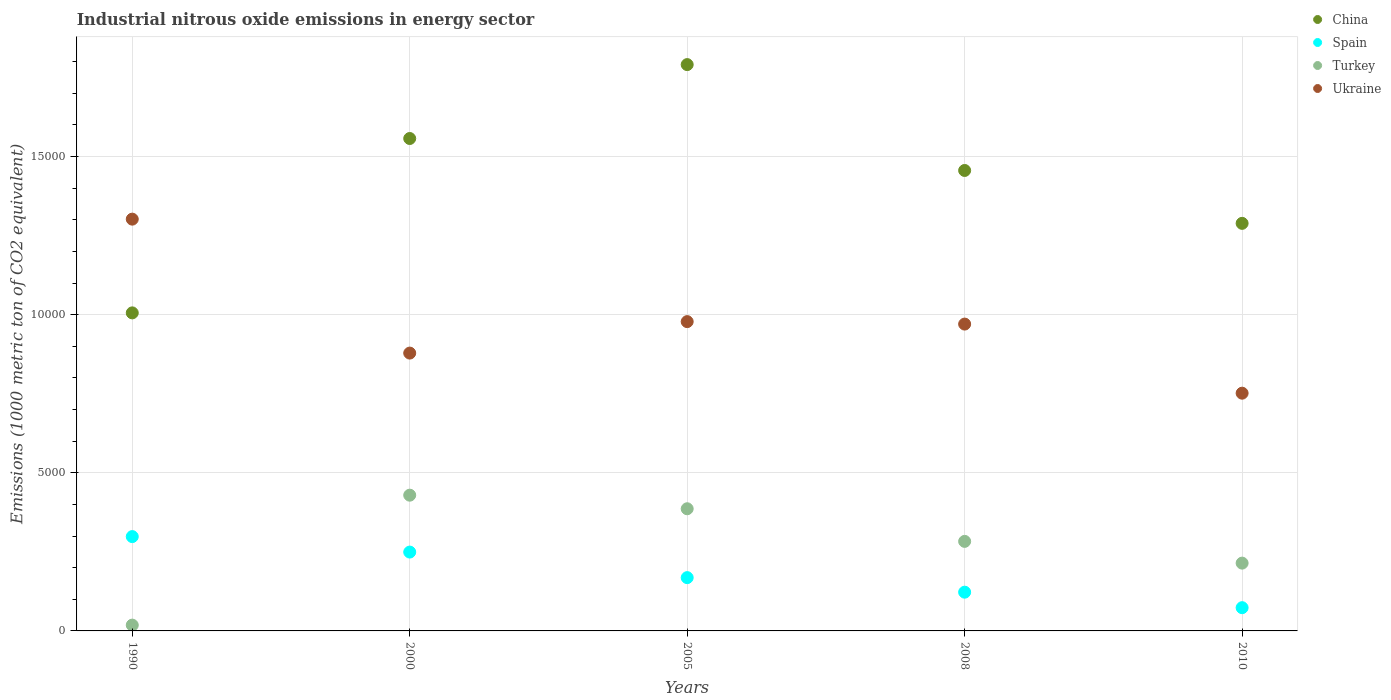How many different coloured dotlines are there?
Your response must be concise. 4. Is the number of dotlines equal to the number of legend labels?
Your answer should be compact. Yes. What is the amount of industrial nitrous oxide emitted in Spain in 1990?
Make the answer very short. 2982.4. Across all years, what is the maximum amount of industrial nitrous oxide emitted in Turkey?
Offer a very short reply. 4292. Across all years, what is the minimum amount of industrial nitrous oxide emitted in Ukraine?
Offer a terse response. 7516.9. In which year was the amount of industrial nitrous oxide emitted in Ukraine maximum?
Offer a terse response. 1990. What is the total amount of industrial nitrous oxide emitted in Spain in the graph?
Make the answer very short. 9120.2. What is the difference between the amount of industrial nitrous oxide emitted in China in 2005 and that in 2010?
Your answer should be very brief. 5019.4. What is the difference between the amount of industrial nitrous oxide emitted in Turkey in 2000 and the amount of industrial nitrous oxide emitted in China in 1990?
Your answer should be very brief. -5764.1. What is the average amount of industrial nitrous oxide emitted in Turkey per year?
Make the answer very short. 2662.68. In the year 2005, what is the difference between the amount of industrial nitrous oxide emitted in China and amount of industrial nitrous oxide emitted in Ukraine?
Keep it short and to the point. 8126.5. What is the ratio of the amount of industrial nitrous oxide emitted in China in 1990 to that in 2010?
Provide a succinct answer. 0.78. Is the amount of industrial nitrous oxide emitted in China in 2008 less than that in 2010?
Keep it short and to the point. No. Is the difference between the amount of industrial nitrous oxide emitted in China in 1990 and 2010 greater than the difference between the amount of industrial nitrous oxide emitted in Ukraine in 1990 and 2010?
Provide a succinct answer. No. What is the difference between the highest and the second highest amount of industrial nitrous oxide emitted in Turkey?
Provide a short and direct response. 429.3. What is the difference between the highest and the lowest amount of industrial nitrous oxide emitted in Turkey?
Keep it short and to the point. 4108.4. In how many years, is the amount of industrial nitrous oxide emitted in Ukraine greater than the average amount of industrial nitrous oxide emitted in Ukraine taken over all years?
Ensure brevity in your answer.  2. Is the sum of the amount of industrial nitrous oxide emitted in Turkey in 2000 and 2010 greater than the maximum amount of industrial nitrous oxide emitted in Spain across all years?
Your answer should be compact. Yes. Is it the case that in every year, the sum of the amount of industrial nitrous oxide emitted in China and amount of industrial nitrous oxide emitted in Turkey  is greater than the sum of amount of industrial nitrous oxide emitted in Spain and amount of industrial nitrous oxide emitted in Ukraine?
Make the answer very short. No. Does the amount of industrial nitrous oxide emitted in China monotonically increase over the years?
Provide a succinct answer. No. Is the amount of industrial nitrous oxide emitted in Turkey strictly greater than the amount of industrial nitrous oxide emitted in Spain over the years?
Offer a terse response. No. How many years are there in the graph?
Give a very brief answer. 5. Where does the legend appear in the graph?
Your answer should be very brief. Top right. What is the title of the graph?
Your answer should be compact. Industrial nitrous oxide emissions in energy sector. Does "Mauritius" appear as one of the legend labels in the graph?
Give a very brief answer. No. What is the label or title of the X-axis?
Your answer should be very brief. Years. What is the label or title of the Y-axis?
Keep it short and to the point. Emissions (1000 metric ton of CO2 equivalent). What is the Emissions (1000 metric ton of CO2 equivalent) in China in 1990?
Your response must be concise. 1.01e+04. What is the Emissions (1000 metric ton of CO2 equivalent) of Spain in 1990?
Your answer should be compact. 2982.4. What is the Emissions (1000 metric ton of CO2 equivalent) of Turkey in 1990?
Your answer should be very brief. 183.6. What is the Emissions (1000 metric ton of CO2 equivalent) in Ukraine in 1990?
Make the answer very short. 1.30e+04. What is the Emissions (1000 metric ton of CO2 equivalent) in China in 2000?
Offer a terse response. 1.56e+04. What is the Emissions (1000 metric ton of CO2 equivalent) in Spain in 2000?
Ensure brevity in your answer.  2493. What is the Emissions (1000 metric ton of CO2 equivalent) in Turkey in 2000?
Your answer should be very brief. 4292. What is the Emissions (1000 metric ton of CO2 equivalent) of Ukraine in 2000?
Offer a terse response. 8784.8. What is the Emissions (1000 metric ton of CO2 equivalent) in China in 2005?
Offer a terse response. 1.79e+04. What is the Emissions (1000 metric ton of CO2 equivalent) in Spain in 2005?
Your answer should be very brief. 1685.1. What is the Emissions (1000 metric ton of CO2 equivalent) of Turkey in 2005?
Offer a very short reply. 3862.7. What is the Emissions (1000 metric ton of CO2 equivalent) of Ukraine in 2005?
Your answer should be very brief. 9779.9. What is the Emissions (1000 metric ton of CO2 equivalent) of China in 2008?
Offer a very short reply. 1.46e+04. What is the Emissions (1000 metric ton of CO2 equivalent) in Spain in 2008?
Offer a terse response. 1224.9. What is the Emissions (1000 metric ton of CO2 equivalent) in Turkey in 2008?
Make the answer very short. 2831.3. What is the Emissions (1000 metric ton of CO2 equivalent) in Ukraine in 2008?
Give a very brief answer. 9701.8. What is the Emissions (1000 metric ton of CO2 equivalent) in China in 2010?
Offer a terse response. 1.29e+04. What is the Emissions (1000 metric ton of CO2 equivalent) of Spain in 2010?
Provide a short and direct response. 734.8. What is the Emissions (1000 metric ton of CO2 equivalent) in Turkey in 2010?
Offer a very short reply. 2143.8. What is the Emissions (1000 metric ton of CO2 equivalent) of Ukraine in 2010?
Provide a succinct answer. 7516.9. Across all years, what is the maximum Emissions (1000 metric ton of CO2 equivalent) of China?
Provide a succinct answer. 1.79e+04. Across all years, what is the maximum Emissions (1000 metric ton of CO2 equivalent) in Spain?
Give a very brief answer. 2982.4. Across all years, what is the maximum Emissions (1000 metric ton of CO2 equivalent) in Turkey?
Offer a very short reply. 4292. Across all years, what is the maximum Emissions (1000 metric ton of CO2 equivalent) in Ukraine?
Ensure brevity in your answer.  1.30e+04. Across all years, what is the minimum Emissions (1000 metric ton of CO2 equivalent) in China?
Provide a short and direct response. 1.01e+04. Across all years, what is the minimum Emissions (1000 metric ton of CO2 equivalent) of Spain?
Your answer should be compact. 734.8. Across all years, what is the minimum Emissions (1000 metric ton of CO2 equivalent) of Turkey?
Provide a succinct answer. 183.6. Across all years, what is the minimum Emissions (1000 metric ton of CO2 equivalent) of Ukraine?
Provide a short and direct response. 7516.9. What is the total Emissions (1000 metric ton of CO2 equivalent) of China in the graph?
Keep it short and to the point. 7.10e+04. What is the total Emissions (1000 metric ton of CO2 equivalent) of Spain in the graph?
Keep it short and to the point. 9120.2. What is the total Emissions (1000 metric ton of CO2 equivalent) of Turkey in the graph?
Give a very brief answer. 1.33e+04. What is the total Emissions (1000 metric ton of CO2 equivalent) in Ukraine in the graph?
Your answer should be very brief. 4.88e+04. What is the difference between the Emissions (1000 metric ton of CO2 equivalent) in China in 1990 and that in 2000?
Provide a succinct answer. -5513.6. What is the difference between the Emissions (1000 metric ton of CO2 equivalent) of Spain in 1990 and that in 2000?
Your answer should be compact. 489.4. What is the difference between the Emissions (1000 metric ton of CO2 equivalent) of Turkey in 1990 and that in 2000?
Your answer should be very brief. -4108.4. What is the difference between the Emissions (1000 metric ton of CO2 equivalent) of Ukraine in 1990 and that in 2000?
Offer a very short reply. 4235.2. What is the difference between the Emissions (1000 metric ton of CO2 equivalent) of China in 1990 and that in 2005?
Your answer should be very brief. -7850.3. What is the difference between the Emissions (1000 metric ton of CO2 equivalent) in Spain in 1990 and that in 2005?
Your answer should be very brief. 1297.3. What is the difference between the Emissions (1000 metric ton of CO2 equivalent) of Turkey in 1990 and that in 2005?
Ensure brevity in your answer.  -3679.1. What is the difference between the Emissions (1000 metric ton of CO2 equivalent) of Ukraine in 1990 and that in 2005?
Keep it short and to the point. 3240.1. What is the difference between the Emissions (1000 metric ton of CO2 equivalent) in China in 1990 and that in 2008?
Keep it short and to the point. -4502.8. What is the difference between the Emissions (1000 metric ton of CO2 equivalent) in Spain in 1990 and that in 2008?
Provide a succinct answer. 1757.5. What is the difference between the Emissions (1000 metric ton of CO2 equivalent) of Turkey in 1990 and that in 2008?
Provide a succinct answer. -2647.7. What is the difference between the Emissions (1000 metric ton of CO2 equivalent) of Ukraine in 1990 and that in 2008?
Make the answer very short. 3318.2. What is the difference between the Emissions (1000 metric ton of CO2 equivalent) in China in 1990 and that in 2010?
Give a very brief answer. -2830.9. What is the difference between the Emissions (1000 metric ton of CO2 equivalent) in Spain in 1990 and that in 2010?
Your answer should be very brief. 2247.6. What is the difference between the Emissions (1000 metric ton of CO2 equivalent) in Turkey in 1990 and that in 2010?
Give a very brief answer. -1960.2. What is the difference between the Emissions (1000 metric ton of CO2 equivalent) of Ukraine in 1990 and that in 2010?
Provide a short and direct response. 5503.1. What is the difference between the Emissions (1000 metric ton of CO2 equivalent) in China in 2000 and that in 2005?
Offer a very short reply. -2336.7. What is the difference between the Emissions (1000 metric ton of CO2 equivalent) in Spain in 2000 and that in 2005?
Ensure brevity in your answer.  807.9. What is the difference between the Emissions (1000 metric ton of CO2 equivalent) of Turkey in 2000 and that in 2005?
Offer a very short reply. 429.3. What is the difference between the Emissions (1000 metric ton of CO2 equivalent) in Ukraine in 2000 and that in 2005?
Make the answer very short. -995.1. What is the difference between the Emissions (1000 metric ton of CO2 equivalent) in China in 2000 and that in 2008?
Make the answer very short. 1010.8. What is the difference between the Emissions (1000 metric ton of CO2 equivalent) in Spain in 2000 and that in 2008?
Your response must be concise. 1268.1. What is the difference between the Emissions (1000 metric ton of CO2 equivalent) in Turkey in 2000 and that in 2008?
Your answer should be very brief. 1460.7. What is the difference between the Emissions (1000 metric ton of CO2 equivalent) in Ukraine in 2000 and that in 2008?
Your response must be concise. -917. What is the difference between the Emissions (1000 metric ton of CO2 equivalent) in China in 2000 and that in 2010?
Ensure brevity in your answer.  2682.7. What is the difference between the Emissions (1000 metric ton of CO2 equivalent) in Spain in 2000 and that in 2010?
Your response must be concise. 1758.2. What is the difference between the Emissions (1000 metric ton of CO2 equivalent) of Turkey in 2000 and that in 2010?
Ensure brevity in your answer.  2148.2. What is the difference between the Emissions (1000 metric ton of CO2 equivalent) in Ukraine in 2000 and that in 2010?
Give a very brief answer. 1267.9. What is the difference between the Emissions (1000 metric ton of CO2 equivalent) of China in 2005 and that in 2008?
Your answer should be compact. 3347.5. What is the difference between the Emissions (1000 metric ton of CO2 equivalent) in Spain in 2005 and that in 2008?
Provide a succinct answer. 460.2. What is the difference between the Emissions (1000 metric ton of CO2 equivalent) of Turkey in 2005 and that in 2008?
Give a very brief answer. 1031.4. What is the difference between the Emissions (1000 metric ton of CO2 equivalent) in Ukraine in 2005 and that in 2008?
Make the answer very short. 78.1. What is the difference between the Emissions (1000 metric ton of CO2 equivalent) in China in 2005 and that in 2010?
Make the answer very short. 5019.4. What is the difference between the Emissions (1000 metric ton of CO2 equivalent) in Spain in 2005 and that in 2010?
Provide a succinct answer. 950.3. What is the difference between the Emissions (1000 metric ton of CO2 equivalent) of Turkey in 2005 and that in 2010?
Give a very brief answer. 1718.9. What is the difference between the Emissions (1000 metric ton of CO2 equivalent) in Ukraine in 2005 and that in 2010?
Provide a succinct answer. 2263. What is the difference between the Emissions (1000 metric ton of CO2 equivalent) in China in 2008 and that in 2010?
Make the answer very short. 1671.9. What is the difference between the Emissions (1000 metric ton of CO2 equivalent) in Spain in 2008 and that in 2010?
Provide a short and direct response. 490.1. What is the difference between the Emissions (1000 metric ton of CO2 equivalent) in Turkey in 2008 and that in 2010?
Your response must be concise. 687.5. What is the difference between the Emissions (1000 metric ton of CO2 equivalent) in Ukraine in 2008 and that in 2010?
Your response must be concise. 2184.9. What is the difference between the Emissions (1000 metric ton of CO2 equivalent) of China in 1990 and the Emissions (1000 metric ton of CO2 equivalent) of Spain in 2000?
Offer a very short reply. 7563.1. What is the difference between the Emissions (1000 metric ton of CO2 equivalent) of China in 1990 and the Emissions (1000 metric ton of CO2 equivalent) of Turkey in 2000?
Your answer should be very brief. 5764.1. What is the difference between the Emissions (1000 metric ton of CO2 equivalent) of China in 1990 and the Emissions (1000 metric ton of CO2 equivalent) of Ukraine in 2000?
Offer a very short reply. 1271.3. What is the difference between the Emissions (1000 metric ton of CO2 equivalent) of Spain in 1990 and the Emissions (1000 metric ton of CO2 equivalent) of Turkey in 2000?
Give a very brief answer. -1309.6. What is the difference between the Emissions (1000 metric ton of CO2 equivalent) of Spain in 1990 and the Emissions (1000 metric ton of CO2 equivalent) of Ukraine in 2000?
Provide a short and direct response. -5802.4. What is the difference between the Emissions (1000 metric ton of CO2 equivalent) of Turkey in 1990 and the Emissions (1000 metric ton of CO2 equivalent) of Ukraine in 2000?
Offer a terse response. -8601.2. What is the difference between the Emissions (1000 metric ton of CO2 equivalent) in China in 1990 and the Emissions (1000 metric ton of CO2 equivalent) in Spain in 2005?
Your answer should be very brief. 8371. What is the difference between the Emissions (1000 metric ton of CO2 equivalent) of China in 1990 and the Emissions (1000 metric ton of CO2 equivalent) of Turkey in 2005?
Give a very brief answer. 6193.4. What is the difference between the Emissions (1000 metric ton of CO2 equivalent) in China in 1990 and the Emissions (1000 metric ton of CO2 equivalent) in Ukraine in 2005?
Give a very brief answer. 276.2. What is the difference between the Emissions (1000 metric ton of CO2 equivalent) in Spain in 1990 and the Emissions (1000 metric ton of CO2 equivalent) in Turkey in 2005?
Your answer should be compact. -880.3. What is the difference between the Emissions (1000 metric ton of CO2 equivalent) of Spain in 1990 and the Emissions (1000 metric ton of CO2 equivalent) of Ukraine in 2005?
Give a very brief answer. -6797.5. What is the difference between the Emissions (1000 metric ton of CO2 equivalent) of Turkey in 1990 and the Emissions (1000 metric ton of CO2 equivalent) of Ukraine in 2005?
Ensure brevity in your answer.  -9596.3. What is the difference between the Emissions (1000 metric ton of CO2 equivalent) in China in 1990 and the Emissions (1000 metric ton of CO2 equivalent) in Spain in 2008?
Keep it short and to the point. 8831.2. What is the difference between the Emissions (1000 metric ton of CO2 equivalent) in China in 1990 and the Emissions (1000 metric ton of CO2 equivalent) in Turkey in 2008?
Make the answer very short. 7224.8. What is the difference between the Emissions (1000 metric ton of CO2 equivalent) of China in 1990 and the Emissions (1000 metric ton of CO2 equivalent) of Ukraine in 2008?
Offer a terse response. 354.3. What is the difference between the Emissions (1000 metric ton of CO2 equivalent) of Spain in 1990 and the Emissions (1000 metric ton of CO2 equivalent) of Turkey in 2008?
Provide a short and direct response. 151.1. What is the difference between the Emissions (1000 metric ton of CO2 equivalent) of Spain in 1990 and the Emissions (1000 metric ton of CO2 equivalent) of Ukraine in 2008?
Give a very brief answer. -6719.4. What is the difference between the Emissions (1000 metric ton of CO2 equivalent) of Turkey in 1990 and the Emissions (1000 metric ton of CO2 equivalent) of Ukraine in 2008?
Offer a terse response. -9518.2. What is the difference between the Emissions (1000 metric ton of CO2 equivalent) in China in 1990 and the Emissions (1000 metric ton of CO2 equivalent) in Spain in 2010?
Your response must be concise. 9321.3. What is the difference between the Emissions (1000 metric ton of CO2 equivalent) in China in 1990 and the Emissions (1000 metric ton of CO2 equivalent) in Turkey in 2010?
Provide a succinct answer. 7912.3. What is the difference between the Emissions (1000 metric ton of CO2 equivalent) in China in 1990 and the Emissions (1000 metric ton of CO2 equivalent) in Ukraine in 2010?
Ensure brevity in your answer.  2539.2. What is the difference between the Emissions (1000 metric ton of CO2 equivalent) of Spain in 1990 and the Emissions (1000 metric ton of CO2 equivalent) of Turkey in 2010?
Provide a short and direct response. 838.6. What is the difference between the Emissions (1000 metric ton of CO2 equivalent) in Spain in 1990 and the Emissions (1000 metric ton of CO2 equivalent) in Ukraine in 2010?
Make the answer very short. -4534.5. What is the difference between the Emissions (1000 metric ton of CO2 equivalent) in Turkey in 1990 and the Emissions (1000 metric ton of CO2 equivalent) in Ukraine in 2010?
Your answer should be very brief. -7333.3. What is the difference between the Emissions (1000 metric ton of CO2 equivalent) of China in 2000 and the Emissions (1000 metric ton of CO2 equivalent) of Spain in 2005?
Ensure brevity in your answer.  1.39e+04. What is the difference between the Emissions (1000 metric ton of CO2 equivalent) in China in 2000 and the Emissions (1000 metric ton of CO2 equivalent) in Turkey in 2005?
Provide a succinct answer. 1.17e+04. What is the difference between the Emissions (1000 metric ton of CO2 equivalent) of China in 2000 and the Emissions (1000 metric ton of CO2 equivalent) of Ukraine in 2005?
Provide a succinct answer. 5789.8. What is the difference between the Emissions (1000 metric ton of CO2 equivalent) in Spain in 2000 and the Emissions (1000 metric ton of CO2 equivalent) in Turkey in 2005?
Provide a short and direct response. -1369.7. What is the difference between the Emissions (1000 metric ton of CO2 equivalent) of Spain in 2000 and the Emissions (1000 metric ton of CO2 equivalent) of Ukraine in 2005?
Provide a succinct answer. -7286.9. What is the difference between the Emissions (1000 metric ton of CO2 equivalent) in Turkey in 2000 and the Emissions (1000 metric ton of CO2 equivalent) in Ukraine in 2005?
Your answer should be very brief. -5487.9. What is the difference between the Emissions (1000 metric ton of CO2 equivalent) in China in 2000 and the Emissions (1000 metric ton of CO2 equivalent) in Spain in 2008?
Your response must be concise. 1.43e+04. What is the difference between the Emissions (1000 metric ton of CO2 equivalent) of China in 2000 and the Emissions (1000 metric ton of CO2 equivalent) of Turkey in 2008?
Give a very brief answer. 1.27e+04. What is the difference between the Emissions (1000 metric ton of CO2 equivalent) of China in 2000 and the Emissions (1000 metric ton of CO2 equivalent) of Ukraine in 2008?
Keep it short and to the point. 5867.9. What is the difference between the Emissions (1000 metric ton of CO2 equivalent) in Spain in 2000 and the Emissions (1000 metric ton of CO2 equivalent) in Turkey in 2008?
Give a very brief answer. -338.3. What is the difference between the Emissions (1000 metric ton of CO2 equivalent) of Spain in 2000 and the Emissions (1000 metric ton of CO2 equivalent) of Ukraine in 2008?
Keep it short and to the point. -7208.8. What is the difference between the Emissions (1000 metric ton of CO2 equivalent) of Turkey in 2000 and the Emissions (1000 metric ton of CO2 equivalent) of Ukraine in 2008?
Ensure brevity in your answer.  -5409.8. What is the difference between the Emissions (1000 metric ton of CO2 equivalent) of China in 2000 and the Emissions (1000 metric ton of CO2 equivalent) of Spain in 2010?
Give a very brief answer. 1.48e+04. What is the difference between the Emissions (1000 metric ton of CO2 equivalent) of China in 2000 and the Emissions (1000 metric ton of CO2 equivalent) of Turkey in 2010?
Make the answer very short. 1.34e+04. What is the difference between the Emissions (1000 metric ton of CO2 equivalent) of China in 2000 and the Emissions (1000 metric ton of CO2 equivalent) of Ukraine in 2010?
Give a very brief answer. 8052.8. What is the difference between the Emissions (1000 metric ton of CO2 equivalent) of Spain in 2000 and the Emissions (1000 metric ton of CO2 equivalent) of Turkey in 2010?
Ensure brevity in your answer.  349.2. What is the difference between the Emissions (1000 metric ton of CO2 equivalent) of Spain in 2000 and the Emissions (1000 metric ton of CO2 equivalent) of Ukraine in 2010?
Offer a terse response. -5023.9. What is the difference between the Emissions (1000 metric ton of CO2 equivalent) in Turkey in 2000 and the Emissions (1000 metric ton of CO2 equivalent) in Ukraine in 2010?
Make the answer very short. -3224.9. What is the difference between the Emissions (1000 metric ton of CO2 equivalent) of China in 2005 and the Emissions (1000 metric ton of CO2 equivalent) of Spain in 2008?
Ensure brevity in your answer.  1.67e+04. What is the difference between the Emissions (1000 metric ton of CO2 equivalent) in China in 2005 and the Emissions (1000 metric ton of CO2 equivalent) in Turkey in 2008?
Provide a succinct answer. 1.51e+04. What is the difference between the Emissions (1000 metric ton of CO2 equivalent) of China in 2005 and the Emissions (1000 metric ton of CO2 equivalent) of Ukraine in 2008?
Provide a succinct answer. 8204.6. What is the difference between the Emissions (1000 metric ton of CO2 equivalent) of Spain in 2005 and the Emissions (1000 metric ton of CO2 equivalent) of Turkey in 2008?
Provide a succinct answer. -1146.2. What is the difference between the Emissions (1000 metric ton of CO2 equivalent) of Spain in 2005 and the Emissions (1000 metric ton of CO2 equivalent) of Ukraine in 2008?
Provide a succinct answer. -8016.7. What is the difference between the Emissions (1000 metric ton of CO2 equivalent) in Turkey in 2005 and the Emissions (1000 metric ton of CO2 equivalent) in Ukraine in 2008?
Keep it short and to the point. -5839.1. What is the difference between the Emissions (1000 metric ton of CO2 equivalent) of China in 2005 and the Emissions (1000 metric ton of CO2 equivalent) of Spain in 2010?
Make the answer very short. 1.72e+04. What is the difference between the Emissions (1000 metric ton of CO2 equivalent) in China in 2005 and the Emissions (1000 metric ton of CO2 equivalent) in Turkey in 2010?
Offer a very short reply. 1.58e+04. What is the difference between the Emissions (1000 metric ton of CO2 equivalent) of China in 2005 and the Emissions (1000 metric ton of CO2 equivalent) of Ukraine in 2010?
Give a very brief answer. 1.04e+04. What is the difference between the Emissions (1000 metric ton of CO2 equivalent) of Spain in 2005 and the Emissions (1000 metric ton of CO2 equivalent) of Turkey in 2010?
Provide a succinct answer. -458.7. What is the difference between the Emissions (1000 metric ton of CO2 equivalent) of Spain in 2005 and the Emissions (1000 metric ton of CO2 equivalent) of Ukraine in 2010?
Your answer should be compact. -5831.8. What is the difference between the Emissions (1000 metric ton of CO2 equivalent) of Turkey in 2005 and the Emissions (1000 metric ton of CO2 equivalent) of Ukraine in 2010?
Ensure brevity in your answer.  -3654.2. What is the difference between the Emissions (1000 metric ton of CO2 equivalent) of China in 2008 and the Emissions (1000 metric ton of CO2 equivalent) of Spain in 2010?
Make the answer very short. 1.38e+04. What is the difference between the Emissions (1000 metric ton of CO2 equivalent) in China in 2008 and the Emissions (1000 metric ton of CO2 equivalent) in Turkey in 2010?
Provide a succinct answer. 1.24e+04. What is the difference between the Emissions (1000 metric ton of CO2 equivalent) in China in 2008 and the Emissions (1000 metric ton of CO2 equivalent) in Ukraine in 2010?
Your answer should be compact. 7042. What is the difference between the Emissions (1000 metric ton of CO2 equivalent) in Spain in 2008 and the Emissions (1000 metric ton of CO2 equivalent) in Turkey in 2010?
Ensure brevity in your answer.  -918.9. What is the difference between the Emissions (1000 metric ton of CO2 equivalent) of Spain in 2008 and the Emissions (1000 metric ton of CO2 equivalent) of Ukraine in 2010?
Provide a short and direct response. -6292. What is the difference between the Emissions (1000 metric ton of CO2 equivalent) of Turkey in 2008 and the Emissions (1000 metric ton of CO2 equivalent) of Ukraine in 2010?
Make the answer very short. -4685.6. What is the average Emissions (1000 metric ton of CO2 equivalent) in China per year?
Offer a very short reply. 1.42e+04. What is the average Emissions (1000 metric ton of CO2 equivalent) in Spain per year?
Provide a short and direct response. 1824.04. What is the average Emissions (1000 metric ton of CO2 equivalent) in Turkey per year?
Your answer should be compact. 2662.68. What is the average Emissions (1000 metric ton of CO2 equivalent) of Ukraine per year?
Offer a very short reply. 9760.68. In the year 1990, what is the difference between the Emissions (1000 metric ton of CO2 equivalent) in China and Emissions (1000 metric ton of CO2 equivalent) in Spain?
Give a very brief answer. 7073.7. In the year 1990, what is the difference between the Emissions (1000 metric ton of CO2 equivalent) of China and Emissions (1000 metric ton of CO2 equivalent) of Turkey?
Offer a very short reply. 9872.5. In the year 1990, what is the difference between the Emissions (1000 metric ton of CO2 equivalent) in China and Emissions (1000 metric ton of CO2 equivalent) in Ukraine?
Your response must be concise. -2963.9. In the year 1990, what is the difference between the Emissions (1000 metric ton of CO2 equivalent) of Spain and Emissions (1000 metric ton of CO2 equivalent) of Turkey?
Your answer should be compact. 2798.8. In the year 1990, what is the difference between the Emissions (1000 metric ton of CO2 equivalent) of Spain and Emissions (1000 metric ton of CO2 equivalent) of Ukraine?
Your response must be concise. -1.00e+04. In the year 1990, what is the difference between the Emissions (1000 metric ton of CO2 equivalent) of Turkey and Emissions (1000 metric ton of CO2 equivalent) of Ukraine?
Offer a very short reply. -1.28e+04. In the year 2000, what is the difference between the Emissions (1000 metric ton of CO2 equivalent) of China and Emissions (1000 metric ton of CO2 equivalent) of Spain?
Offer a terse response. 1.31e+04. In the year 2000, what is the difference between the Emissions (1000 metric ton of CO2 equivalent) of China and Emissions (1000 metric ton of CO2 equivalent) of Turkey?
Provide a succinct answer. 1.13e+04. In the year 2000, what is the difference between the Emissions (1000 metric ton of CO2 equivalent) of China and Emissions (1000 metric ton of CO2 equivalent) of Ukraine?
Keep it short and to the point. 6784.9. In the year 2000, what is the difference between the Emissions (1000 metric ton of CO2 equivalent) in Spain and Emissions (1000 metric ton of CO2 equivalent) in Turkey?
Offer a terse response. -1799. In the year 2000, what is the difference between the Emissions (1000 metric ton of CO2 equivalent) of Spain and Emissions (1000 metric ton of CO2 equivalent) of Ukraine?
Make the answer very short. -6291.8. In the year 2000, what is the difference between the Emissions (1000 metric ton of CO2 equivalent) of Turkey and Emissions (1000 metric ton of CO2 equivalent) of Ukraine?
Make the answer very short. -4492.8. In the year 2005, what is the difference between the Emissions (1000 metric ton of CO2 equivalent) in China and Emissions (1000 metric ton of CO2 equivalent) in Spain?
Your answer should be very brief. 1.62e+04. In the year 2005, what is the difference between the Emissions (1000 metric ton of CO2 equivalent) in China and Emissions (1000 metric ton of CO2 equivalent) in Turkey?
Your answer should be compact. 1.40e+04. In the year 2005, what is the difference between the Emissions (1000 metric ton of CO2 equivalent) in China and Emissions (1000 metric ton of CO2 equivalent) in Ukraine?
Give a very brief answer. 8126.5. In the year 2005, what is the difference between the Emissions (1000 metric ton of CO2 equivalent) in Spain and Emissions (1000 metric ton of CO2 equivalent) in Turkey?
Your answer should be very brief. -2177.6. In the year 2005, what is the difference between the Emissions (1000 metric ton of CO2 equivalent) in Spain and Emissions (1000 metric ton of CO2 equivalent) in Ukraine?
Your answer should be compact. -8094.8. In the year 2005, what is the difference between the Emissions (1000 metric ton of CO2 equivalent) of Turkey and Emissions (1000 metric ton of CO2 equivalent) of Ukraine?
Make the answer very short. -5917.2. In the year 2008, what is the difference between the Emissions (1000 metric ton of CO2 equivalent) in China and Emissions (1000 metric ton of CO2 equivalent) in Spain?
Give a very brief answer. 1.33e+04. In the year 2008, what is the difference between the Emissions (1000 metric ton of CO2 equivalent) of China and Emissions (1000 metric ton of CO2 equivalent) of Turkey?
Your response must be concise. 1.17e+04. In the year 2008, what is the difference between the Emissions (1000 metric ton of CO2 equivalent) of China and Emissions (1000 metric ton of CO2 equivalent) of Ukraine?
Offer a terse response. 4857.1. In the year 2008, what is the difference between the Emissions (1000 metric ton of CO2 equivalent) of Spain and Emissions (1000 metric ton of CO2 equivalent) of Turkey?
Make the answer very short. -1606.4. In the year 2008, what is the difference between the Emissions (1000 metric ton of CO2 equivalent) of Spain and Emissions (1000 metric ton of CO2 equivalent) of Ukraine?
Make the answer very short. -8476.9. In the year 2008, what is the difference between the Emissions (1000 metric ton of CO2 equivalent) in Turkey and Emissions (1000 metric ton of CO2 equivalent) in Ukraine?
Make the answer very short. -6870.5. In the year 2010, what is the difference between the Emissions (1000 metric ton of CO2 equivalent) in China and Emissions (1000 metric ton of CO2 equivalent) in Spain?
Make the answer very short. 1.22e+04. In the year 2010, what is the difference between the Emissions (1000 metric ton of CO2 equivalent) of China and Emissions (1000 metric ton of CO2 equivalent) of Turkey?
Make the answer very short. 1.07e+04. In the year 2010, what is the difference between the Emissions (1000 metric ton of CO2 equivalent) of China and Emissions (1000 metric ton of CO2 equivalent) of Ukraine?
Your answer should be compact. 5370.1. In the year 2010, what is the difference between the Emissions (1000 metric ton of CO2 equivalent) in Spain and Emissions (1000 metric ton of CO2 equivalent) in Turkey?
Your answer should be very brief. -1409. In the year 2010, what is the difference between the Emissions (1000 metric ton of CO2 equivalent) in Spain and Emissions (1000 metric ton of CO2 equivalent) in Ukraine?
Ensure brevity in your answer.  -6782.1. In the year 2010, what is the difference between the Emissions (1000 metric ton of CO2 equivalent) of Turkey and Emissions (1000 metric ton of CO2 equivalent) of Ukraine?
Offer a terse response. -5373.1. What is the ratio of the Emissions (1000 metric ton of CO2 equivalent) of China in 1990 to that in 2000?
Your answer should be compact. 0.65. What is the ratio of the Emissions (1000 metric ton of CO2 equivalent) in Spain in 1990 to that in 2000?
Your response must be concise. 1.2. What is the ratio of the Emissions (1000 metric ton of CO2 equivalent) in Turkey in 1990 to that in 2000?
Keep it short and to the point. 0.04. What is the ratio of the Emissions (1000 metric ton of CO2 equivalent) of Ukraine in 1990 to that in 2000?
Provide a succinct answer. 1.48. What is the ratio of the Emissions (1000 metric ton of CO2 equivalent) in China in 1990 to that in 2005?
Offer a terse response. 0.56. What is the ratio of the Emissions (1000 metric ton of CO2 equivalent) in Spain in 1990 to that in 2005?
Offer a terse response. 1.77. What is the ratio of the Emissions (1000 metric ton of CO2 equivalent) of Turkey in 1990 to that in 2005?
Your response must be concise. 0.05. What is the ratio of the Emissions (1000 metric ton of CO2 equivalent) of Ukraine in 1990 to that in 2005?
Ensure brevity in your answer.  1.33. What is the ratio of the Emissions (1000 metric ton of CO2 equivalent) of China in 1990 to that in 2008?
Ensure brevity in your answer.  0.69. What is the ratio of the Emissions (1000 metric ton of CO2 equivalent) of Spain in 1990 to that in 2008?
Make the answer very short. 2.43. What is the ratio of the Emissions (1000 metric ton of CO2 equivalent) of Turkey in 1990 to that in 2008?
Your answer should be very brief. 0.06. What is the ratio of the Emissions (1000 metric ton of CO2 equivalent) in Ukraine in 1990 to that in 2008?
Ensure brevity in your answer.  1.34. What is the ratio of the Emissions (1000 metric ton of CO2 equivalent) in China in 1990 to that in 2010?
Your response must be concise. 0.78. What is the ratio of the Emissions (1000 metric ton of CO2 equivalent) in Spain in 1990 to that in 2010?
Offer a very short reply. 4.06. What is the ratio of the Emissions (1000 metric ton of CO2 equivalent) of Turkey in 1990 to that in 2010?
Your response must be concise. 0.09. What is the ratio of the Emissions (1000 metric ton of CO2 equivalent) in Ukraine in 1990 to that in 2010?
Provide a short and direct response. 1.73. What is the ratio of the Emissions (1000 metric ton of CO2 equivalent) of China in 2000 to that in 2005?
Make the answer very short. 0.87. What is the ratio of the Emissions (1000 metric ton of CO2 equivalent) in Spain in 2000 to that in 2005?
Give a very brief answer. 1.48. What is the ratio of the Emissions (1000 metric ton of CO2 equivalent) in Turkey in 2000 to that in 2005?
Ensure brevity in your answer.  1.11. What is the ratio of the Emissions (1000 metric ton of CO2 equivalent) of Ukraine in 2000 to that in 2005?
Ensure brevity in your answer.  0.9. What is the ratio of the Emissions (1000 metric ton of CO2 equivalent) of China in 2000 to that in 2008?
Offer a very short reply. 1.07. What is the ratio of the Emissions (1000 metric ton of CO2 equivalent) in Spain in 2000 to that in 2008?
Offer a very short reply. 2.04. What is the ratio of the Emissions (1000 metric ton of CO2 equivalent) of Turkey in 2000 to that in 2008?
Keep it short and to the point. 1.52. What is the ratio of the Emissions (1000 metric ton of CO2 equivalent) of Ukraine in 2000 to that in 2008?
Give a very brief answer. 0.91. What is the ratio of the Emissions (1000 metric ton of CO2 equivalent) of China in 2000 to that in 2010?
Ensure brevity in your answer.  1.21. What is the ratio of the Emissions (1000 metric ton of CO2 equivalent) of Spain in 2000 to that in 2010?
Give a very brief answer. 3.39. What is the ratio of the Emissions (1000 metric ton of CO2 equivalent) of Turkey in 2000 to that in 2010?
Your answer should be very brief. 2. What is the ratio of the Emissions (1000 metric ton of CO2 equivalent) in Ukraine in 2000 to that in 2010?
Your answer should be very brief. 1.17. What is the ratio of the Emissions (1000 metric ton of CO2 equivalent) of China in 2005 to that in 2008?
Ensure brevity in your answer.  1.23. What is the ratio of the Emissions (1000 metric ton of CO2 equivalent) in Spain in 2005 to that in 2008?
Offer a terse response. 1.38. What is the ratio of the Emissions (1000 metric ton of CO2 equivalent) in Turkey in 2005 to that in 2008?
Make the answer very short. 1.36. What is the ratio of the Emissions (1000 metric ton of CO2 equivalent) of Ukraine in 2005 to that in 2008?
Your answer should be very brief. 1.01. What is the ratio of the Emissions (1000 metric ton of CO2 equivalent) of China in 2005 to that in 2010?
Offer a terse response. 1.39. What is the ratio of the Emissions (1000 metric ton of CO2 equivalent) in Spain in 2005 to that in 2010?
Offer a terse response. 2.29. What is the ratio of the Emissions (1000 metric ton of CO2 equivalent) in Turkey in 2005 to that in 2010?
Provide a succinct answer. 1.8. What is the ratio of the Emissions (1000 metric ton of CO2 equivalent) of Ukraine in 2005 to that in 2010?
Make the answer very short. 1.3. What is the ratio of the Emissions (1000 metric ton of CO2 equivalent) of China in 2008 to that in 2010?
Your response must be concise. 1.13. What is the ratio of the Emissions (1000 metric ton of CO2 equivalent) of Spain in 2008 to that in 2010?
Provide a short and direct response. 1.67. What is the ratio of the Emissions (1000 metric ton of CO2 equivalent) in Turkey in 2008 to that in 2010?
Provide a succinct answer. 1.32. What is the ratio of the Emissions (1000 metric ton of CO2 equivalent) in Ukraine in 2008 to that in 2010?
Ensure brevity in your answer.  1.29. What is the difference between the highest and the second highest Emissions (1000 metric ton of CO2 equivalent) in China?
Provide a succinct answer. 2336.7. What is the difference between the highest and the second highest Emissions (1000 metric ton of CO2 equivalent) in Spain?
Your answer should be very brief. 489.4. What is the difference between the highest and the second highest Emissions (1000 metric ton of CO2 equivalent) in Turkey?
Your answer should be compact. 429.3. What is the difference between the highest and the second highest Emissions (1000 metric ton of CO2 equivalent) of Ukraine?
Provide a short and direct response. 3240.1. What is the difference between the highest and the lowest Emissions (1000 metric ton of CO2 equivalent) of China?
Your answer should be compact. 7850.3. What is the difference between the highest and the lowest Emissions (1000 metric ton of CO2 equivalent) in Spain?
Your response must be concise. 2247.6. What is the difference between the highest and the lowest Emissions (1000 metric ton of CO2 equivalent) of Turkey?
Your response must be concise. 4108.4. What is the difference between the highest and the lowest Emissions (1000 metric ton of CO2 equivalent) in Ukraine?
Provide a succinct answer. 5503.1. 